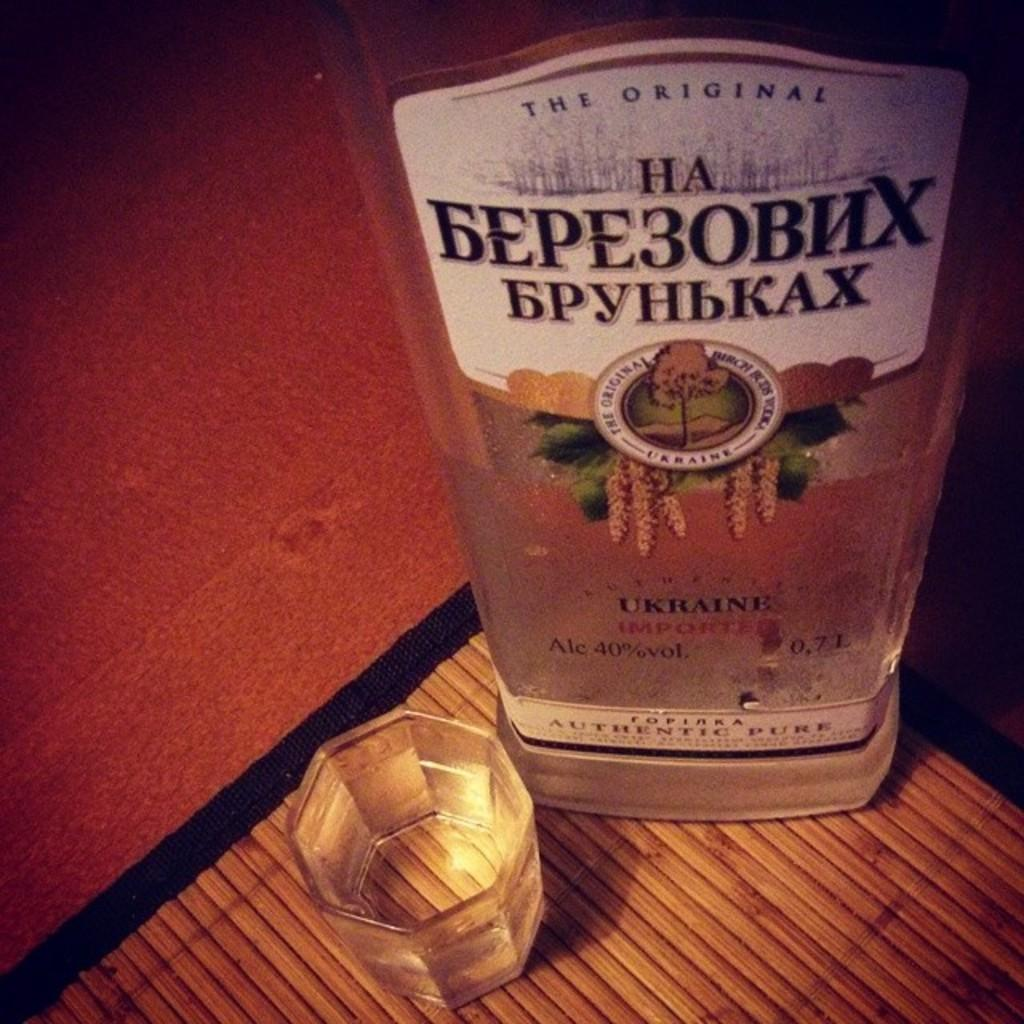<image>
Summarize the visual content of the image. A bottle of alcohol from the Ukraine sits next to an octagonal drinking glass. 